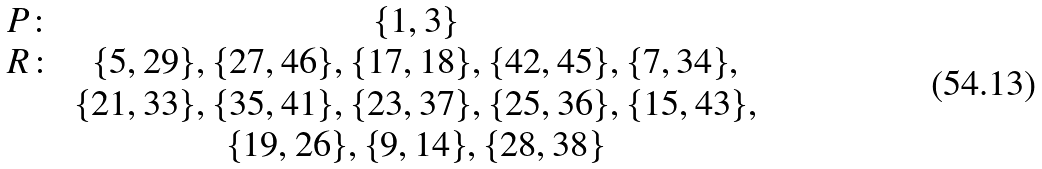Convert formula to latex. <formula><loc_0><loc_0><loc_500><loc_500>\begin{array} { c c c } P \colon & \{ 1 , 3 \} \\ R \colon & \{ 5 , 2 9 \} , \{ 2 7 , 4 6 \} , \{ 1 7 , 1 8 \} , \{ 4 2 , 4 5 \} , \{ 7 , 3 4 \} , \\ & \{ 2 1 , 3 3 \} , \{ 3 5 , 4 1 \} , \{ 2 3 , 3 7 \} , \{ 2 5 , 3 6 \} , \{ 1 5 , 4 3 \} , \\ & \{ 1 9 , 2 6 \} , \{ 9 , 1 4 \} , \{ 2 8 , 3 8 \} \\ \end{array}</formula> 